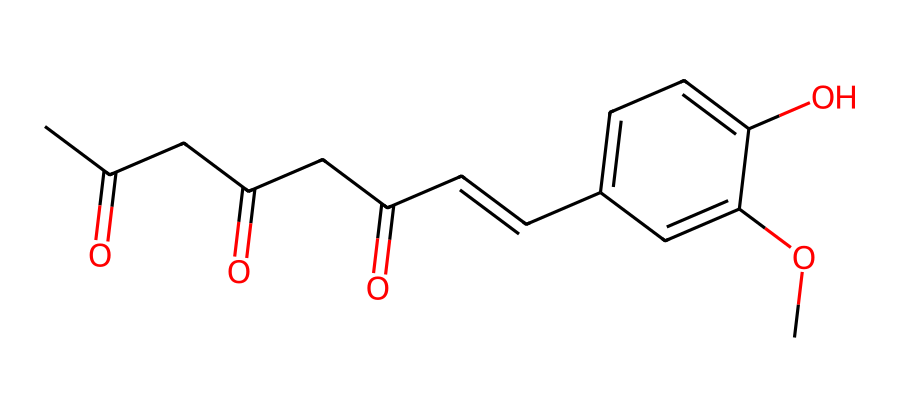What is the molecular formula of curcumin? To determine the molecular formula, count the number of each type of atom in the SMILES representation. From the provided SMILES, we note the presence of carbon (C), hydrogen (H), and oxygen (O) atoms. Counting gives us 21 carbons, 20 hydrogens, and 6 oxygens, leading to the molecular formula C21H20O6.
Answer: C21H20O6 How many double bonds are present in curcumin? In the SMILES notation, double bonds are typically indicated by the "=" symbol. By examining the structure, we find three instances of a double bond: one between the first carbonyl carbon and the adjacent carbon, another in the middle of the chain, and one between the two carbons of the alkene. Therefore, there are three double bonds.
Answer: 3 What functional groups can be identified in curcumin? A functional group is a specific grouping of atoms within a molecule that is responsible for its characteristic chemical reactions. In the case of curcumin, the structure shows ketones (CC(=O)CC(=O)), an alkene (C=C), and methoxy groups (–OCH3). Thus, the functional groups identified are ketone, alkene, and ether.
Answer: ketone, alkene, ether Is curcumin an antioxidant? Curcumin is known for its antioxidant properties, which means it can neutralize free radicals and prevent oxidative stress in the body. This is primarily due to the presence of phenolic hydroxyl groups in its structure that can donate electrons.
Answer: Yes What is the significance of the phenolic ring in curcumin? The phenolic hydroxyl groups present in the ring structure are crucial for antioxidant activity. These groups can intercede in oxidative reactions, providing protons to free radicals, thus stabilizing them. The structural configuration enhances its capacity to act as a radical scavenger.
Answer: Antioxidant activity How many rings are present in the structure of curcumin? Upon analyzing the provided structure, we see one aromatic ring represented by 'c1ccc(...' which indicates a 6-membered ring with alternating double bonds. Thus, there is one ring present in curcumin.
Answer: 1 